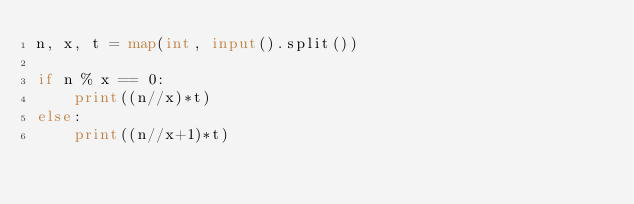Convert code to text. <code><loc_0><loc_0><loc_500><loc_500><_Python_>n, x, t = map(int, input().split())

if n % x == 0:
    print((n//x)*t)
else:
    print((n//x+1)*t)</code> 